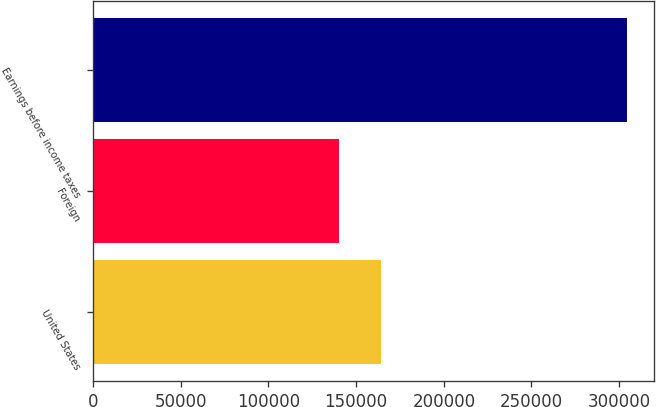Convert chart. <chart><loc_0><loc_0><loc_500><loc_500><bar_chart><fcel>United States<fcel>Foreign<fcel>Earnings before income taxes<nl><fcel>164122<fcel>140370<fcel>304492<nl></chart> 